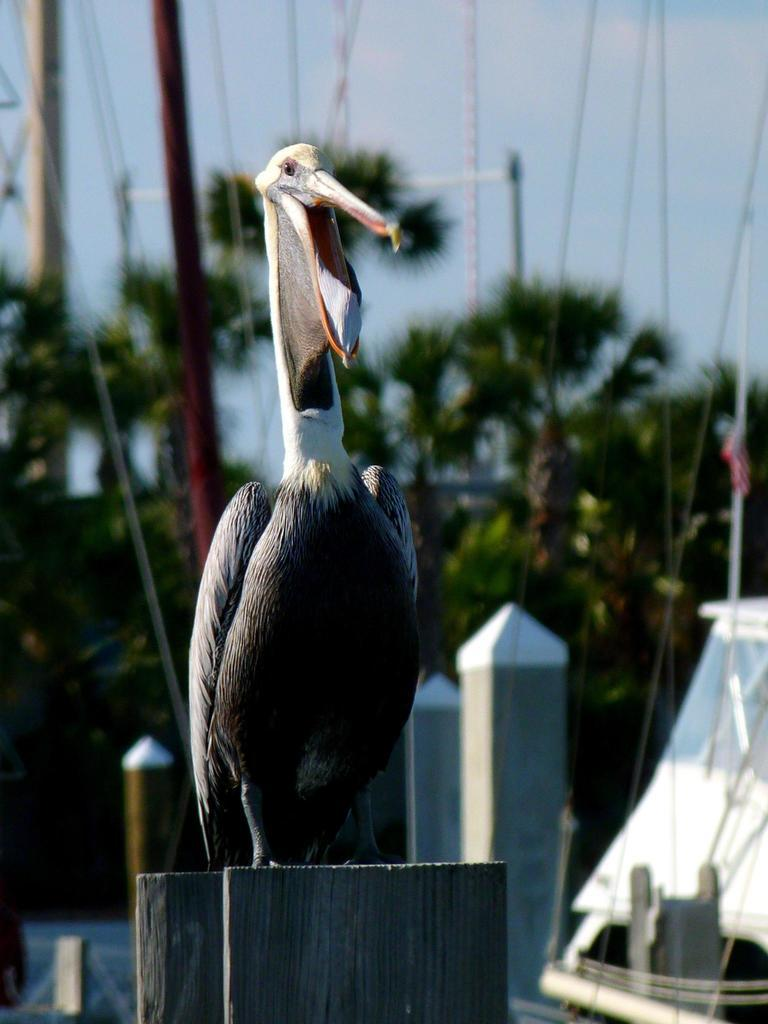What type of animal is in the image? There is a bird in the image. What is the bird sitting on? The bird is on a wooden object. What can be seen in the background of the image? There are poles, trees, and clouds in the sky in the background of the image. What design is the bird rubbing on its mind in the image? There is no indication in the image that the bird is rubbing any design on its mind. 